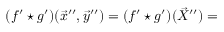<formula> <loc_0><loc_0><loc_500><loc_500>( f ^ { \prime } ^ { * } g ^ { \prime } ) ( \vec { x } ^ { \prime \prime } , \vec { y } ^ { \prime \prime } ) = ( f ^ { \prime } ^ { * } g ^ { \prime } ) ( \vec { X } ^ { \prime \prime } ) =</formula> 